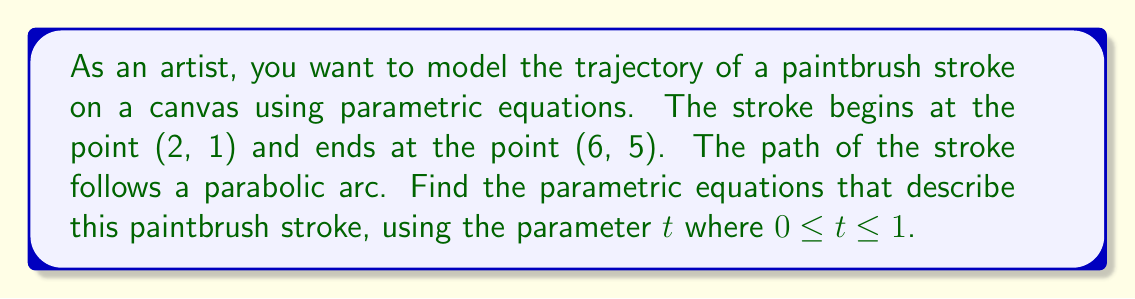Could you help me with this problem? To model the paintbrush stroke using parametric equations, we'll follow these steps:

1) First, we need to recognize that the x and y coordinates will be functions of the parameter $t$. We'll use the general forms:

   $x = a_1t + b_1$
   $y = a_2t^2 + b_2t + c_2$

   Here, we use a linear function for x and a quadratic function for y to create the parabolic arc.

2) We know the starting point (2, 1) corresponds to $t = 0$, and the ending point (6, 5) corresponds to $t = 1$. Let's use these to set up equations:

   For $t = 0$: $x = 2$, $y = 1$
   For $t = 1$: $x = 6$, $y = 5$

3) For the x-coordinate:
   $x = a_1t + b_1$
   At $t = 0$: $2 = b_1$
   At $t = 1$: $6 = a_1 + 2$

   Solving these, we get: $a_1 = 4$, $b_1 = 2$
   So, $x = 4t + 2$

4) For the y-coordinate:
   $y = a_2t^2 + b_2t + c_2$
   At $t = 0$: $1 = c_2$
   At $t = 1$: $5 = a_2 + b_2 + 1$

5) We need one more condition to solve for $a_2$ and $b_2$. Let's use the fact that the stroke is symmetric. The midpoint of the stroke should occur at $t = 0.5$. At this point, the y-coordinate should be halfway between 1 and 5, which is 3.

   At $t = 0.5$: $3 = a_2(0.5)^2 + b_2(0.5) + 1$

6) Now we have a system of two equations:
   $5 = a_2 + b_2 + 1$
   $3 = 0.25a_2 + 0.5b_2 + 1$

   Solving these, we get: $a_2 = 4$, $b_2 = 0$

Therefore, the y-coordinate equation is: $y = 4t^2 + 1$
Answer: The parametric equations describing the paintbrush stroke are:

$$x = 4t + 2$$
$$y = 4t^2 + 1$$

where $0 \leq t \leq 1$ 